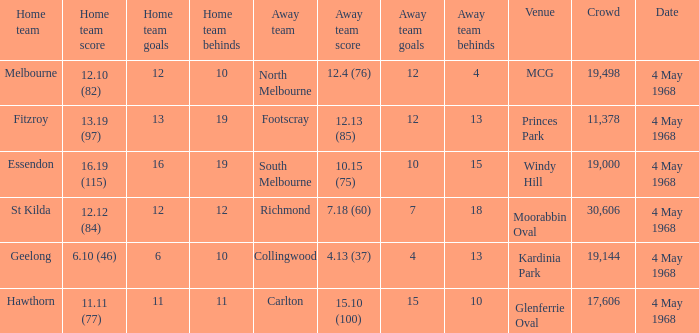What away team played at Kardinia Park? 4.13 (37). 